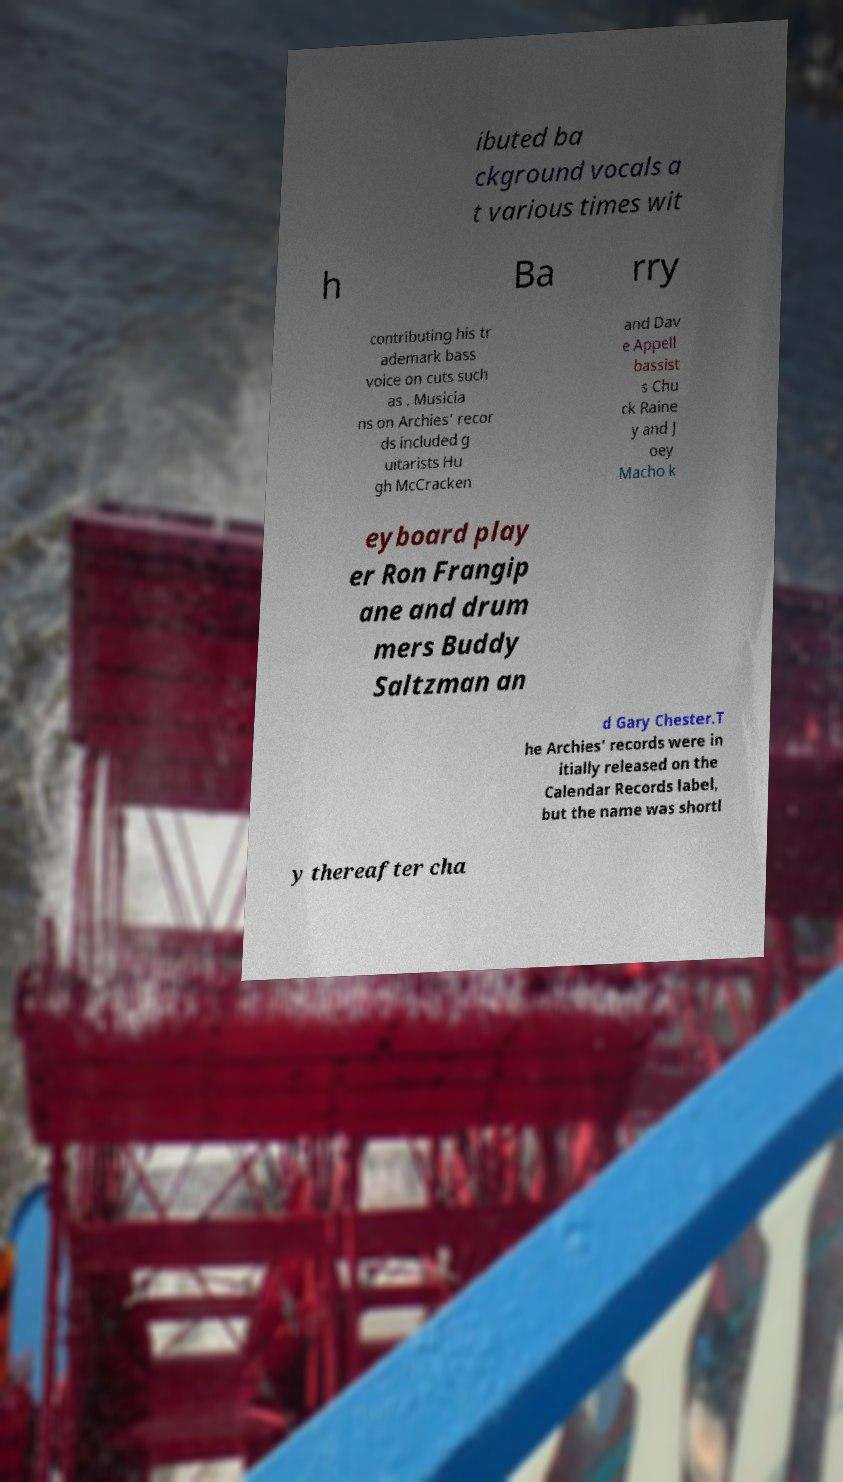I need the written content from this picture converted into text. Can you do that? ibuted ba ckground vocals a t various times wit h Ba rry contributing his tr ademark bass voice on cuts such as . Musicia ns on Archies' recor ds included g uitarists Hu gh McCracken and Dav e Appell bassist s Chu ck Raine y and J oey Macho k eyboard play er Ron Frangip ane and drum mers Buddy Saltzman an d Gary Chester.T he Archies' records were in itially released on the Calendar Records label, but the name was shortl y thereafter cha 